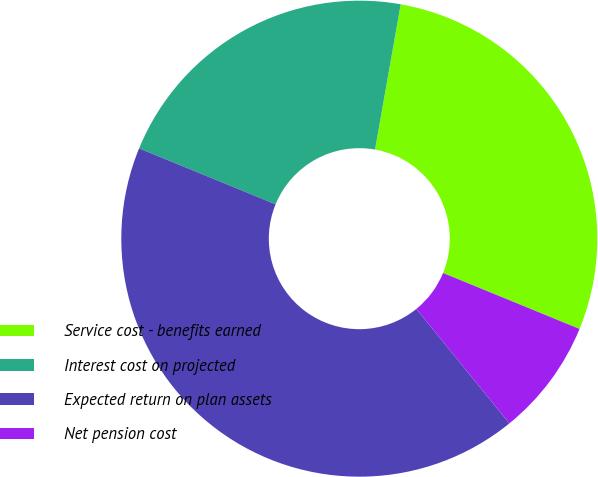<chart> <loc_0><loc_0><loc_500><loc_500><pie_chart><fcel>Service cost - benefits earned<fcel>Interest cost on projected<fcel>Expected return on plan assets<fcel>Net pension cost<nl><fcel>28.41%<fcel>21.59%<fcel>42.05%<fcel>7.95%<nl></chart> 